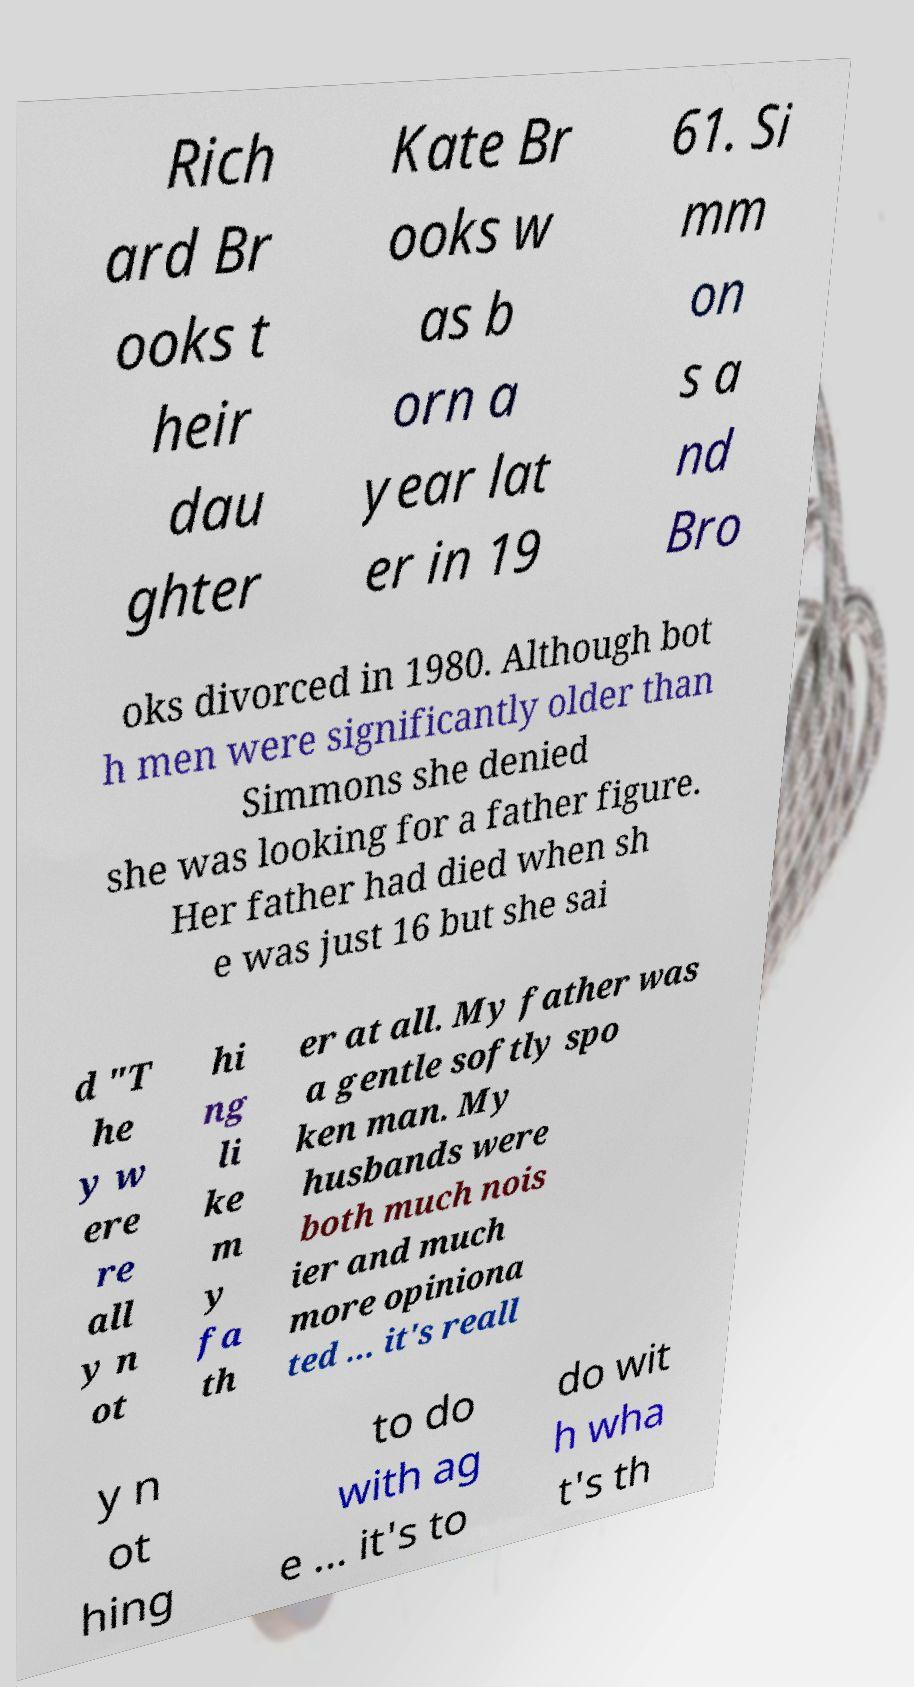Could you assist in decoding the text presented in this image and type it out clearly? Rich ard Br ooks t heir dau ghter Kate Br ooks w as b orn a year lat er in 19 61. Si mm on s a nd Bro oks divorced in 1980. Although bot h men were significantly older than Simmons she denied she was looking for a father figure. Her father had died when sh e was just 16 but she sai d "T he y w ere re all y n ot hi ng li ke m y fa th er at all. My father was a gentle softly spo ken man. My husbands were both much nois ier and much more opiniona ted ... it's reall y n ot hing to do with ag e ... it's to do wit h wha t's th 